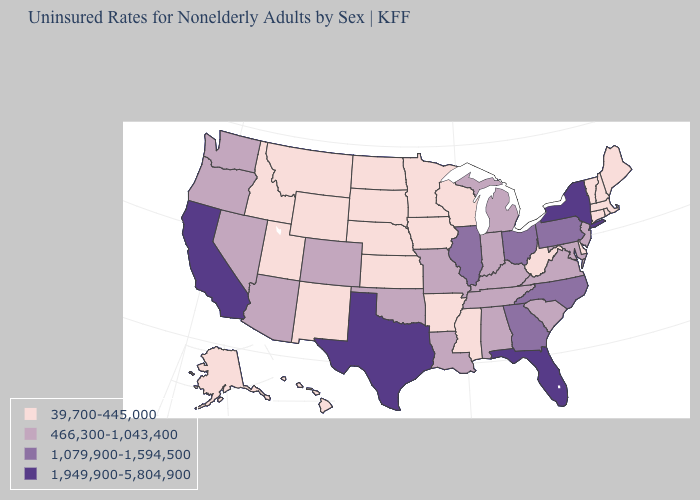Among the states that border Mississippi , does Arkansas have the lowest value?
Keep it brief. Yes. Which states hav the highest value in the West?
Be succinct. California. Which states hav the highest value in the South?
Be succinct. Florida, Texas. Is the legend a continuous bar?
Give a very brief answer. No. Does Wyoming have a lower value than Louisiana?
Short answer required. Yes. Which states hav the highest value in the West?
Be succinct. California. Name the states that have a value in the range 39,700-445,000?
Quick response, please. Alaska, Arkansas, Connecticut, Delaware, Hawaii, Idaho, Iowa, Kansas, Maine, Massachusetts, Minnesota, Mississippi, Montana, Nebraska, New Hampshire, New Mexico, North Dakota, Rhode Island, South Dakota, Utah, Vermont, West Virginia, Wisconsin, Wyoming. Name the states that have a value in the range 1,079,900-1,594,500?
Answer briefly. Georgia, Illinois, North Carolina, Ohio, Pennsylvania. What is the value of Arizona?
Give a very brief answer. 466,300-1,043,400. Among the states that border Mississippi , which have the highest value?
Short answer required. Alabama, Louisiana, Tennessee. What is the highest value in the USA?
Write a very short answer. 1,949,900-5,804,900. Which states have the lowest value in the USA?
Answer briefly. Alaska, Arkansas, Connecticut, Delaware, Hawaii, Idaho, Iowa, Kansas, Maine, Massachusetts, Minnesota, Mississippi, Montana, Nebraska, New Hampshire, New Mexico, North Dakota, Rhode Island, South Dakota, Utah, Vermont, West Virginia, Wisconsin, Wyoming. What is the value of Illinois?
Short answer required. 1,079,900-1,594,500. Does the map have missing data?
Short answer required. No. What is the value of Rhode Island?
Quick response, please. 39,700-445,000. 